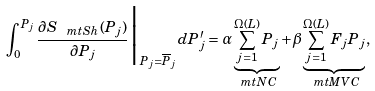<formula> <loc_0><loc_0><loc_500><loc_500>\int _ { 0 } ^ { P _ { j } } \frac { \partial S _ { \ m t { S h } } ( P _ { j } ) } { \partial P _ { j } } \Big | _ { P _ { j } = \overline { P } _ { j } } d P ^ { \prime } _ { j } & = \alpha \underbrace { \sum _ { j = 1 } ^ { \Omega ( L ) } P _ { j } } _ { \ m t { N C } } + \beta \underbrace { \sum _ { j = 1 } ^ { \Omega ( L ) } F _ { j } P _ { j } } _ { \ m t { M V C } } ,</formula> 